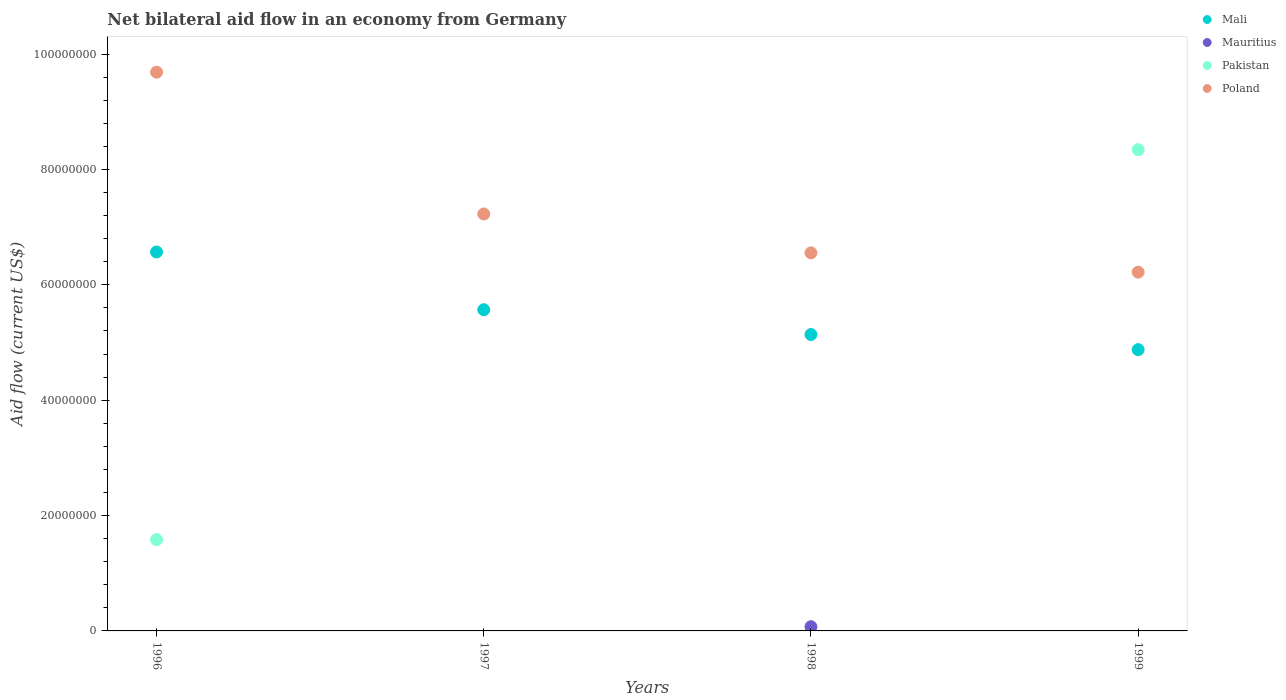How many different coloured dotlines are there?
Offer a terse response. 4. Is the number of dotlines equal to the number of legend labels?
Give a very brief answer. No. What is the net bilateral aid flow in Mali in 1996?
Offer a terse response. 6.57e+07. Across all years, what is the maximum net bilateral aid flow in Mauritius?
Keep it short and to the point. 7.30e+05. In which year was the net bilateral aid flow in Poland maximum?
Your response must be concise. 1996. What is the total net bilateral aid flow in Mauritius in the graph?
Your response must be concise. 7.30e+05. What is the difference between the net bilateral aid flow in Mali in 1998 and that in 1999?
Your response must be concise. 2.62e+06. What is the difference between the net bilateral aid flow in Poland in 1997 and the net bilateral aid flow in Mauritius in 1999?
Offer a very short reply. 7.23e+07. What is the average net bilateral aid flow in Pakistan per year?
Give a very brief answer. 2.48e+07. In the year 1998, what is the difference between the net bilateral aid flow in Mauritius and net bilateral aid flow in Poland?
Offer a very short reply. -6.48e+07. In how many years, is the net bilateral aid flow in Mali greater than 92000000 US$?
Your response must be concise. 0. What is the ratio of the net bilateral aid flow in Mali in 1998 to that in 1999?
Your response must be concise. 1.05. Is the net bilateral aid flow in Poland in 1997 less than that in 1999?
Ensure brevity in your answer.  No. What is the difference between the highest and the second highest net bilateral aid flow in Mali?
Provide a succinct answer. 1.00e+07. What is the difference between the highest and the lowest net bilateral aid flow in Mali?
Keep it short and to the point. 1.69e+07. Is the sum of the net bilateral aid flow in Mali in 1996 and 1998 greater than the maximum net bilateral aid flow in Mauritius across all years?
Provide a short and direct response. Yes. Is it the case that in every year, the sum of the net bilateral aid flow in Mali and net bilateral aid flow in Mauritius  is greater than the net bilateral aid flow in Pakistan?
Keep it short and to the point. No. How many dotlines are there?
Your answer should be very brief. 4. How many years are there in the graph?
Offer a terse response. 4. What is the difference between two consecutive major ticks on the Y-axis?
Your answer should be compact. 2.00e+07. Are the values on the major ticks of Y-axis written in scientific E-notation?
Your answer should be very brief. No. Does the graph contain grids?
Give a very brief answer. No. Where does the legend appear in the graph?
Ensure brevity in your answer.  Top right. What is the title of the graph?
Your answer should be compact. Net bilateral aid flow in an economy from Germany. Does "Congo (Republic)" appear as one of the legend labels in the graph?
Your response must be concise. No. What is the label or title of the X-axis?
Provide a succinct answer. Years. What is the Aid flow (current US$) in Mali in 1996?
Your answer should be very brief. 6.57e+07. What is the Aid flow (current US$) in Mauritius in 1996?
Your answer should be very brief. 0. What is the Aid flow (current US$) of Pakistan in 1996?
Your answer should be compact. 1.58e+07. What is the Aid flow (current US$) of Poland in 1996?
Keep it short and to the point. 9.69e+07. What is the Aid flow (current US$) of Mali in 1997?
Make the answer very short. 5.57e+07. What is the Aid flow (current US$) of Mauritius in 1997?
Offer a terse response. 0. What is the Aid flow (current US$) in Poland in 1997?
Provide a succinct answer. 7.23e+07. What is the Aid flow (current US$) in Mali in 1998?
Make the answer very short. 5.14e+07. What is the Aid flow (current US$) in Mauritius in 1998?
Make the answer very short. 7.30e+05. What is the Aid flow (current US$) in Pakistan in 1998?
Your response must be concise. 0. What is the Aid flow (current US$) of Poland in 1998?
Make the answer very short. 6.55e+07. What is the Aid flow (current US$) of Mali in 1999?
Your answer should be very brief. 4.88e+07. What is the Aid flow (current US$) in Pakistan in 1999?
Keep it short and to the point. 8.34e+07. What is the Aid flow (current US$) in Poland in 1999?
Offer a terse response. 6.22e+07. Across all years, what is the maximum Aid flow (current US$) of Mali?
Your answer should be very brief. 6.57e+07. Across all years, what is the maximum Aid flow (current US$) of Mauritius?
Offer a terse response. 7.30e+05. Across all years, what is the maximum Aid flow (current US$) of Pakistan?
Keep it short and to the point. 8.34e+07. Across all years, what is the maximum Aid flow (current US$) of Poland?
Your response must be concise. 9.69e+07. Across all years, what is the minimum Aid flow (current US$) of Mali?
Keep it short and to the point. 4.88e+07. Across all years, what is the minimum Aid flow (current US$) in Mauritius?
Give a very brief answer. 0. Across all years, what is the minimum Aid flow (current US$) of Pakistan?
Give a very brief answer. 0. Across all years, what is the minimum Aid flow (current US$) of Poland?
Your answer should be very brief. 6.22e+07. What is the total Aid flow (current US$) in Mali in the graph?
Keep it short and to the point. 2.22e+08. What is the total Aid flow (current US$) in Mauritius in the graph?
Make the answer very short. 7.30e+05. What is the total Aid flow (current US$) of Pakistan in the graph?
Your answer should be very brief. 9.92e+07. What is the total Aid flow (current US$) of Poland in the graph?
Your answer should be compact. 2.97e+08. What is the difference between the Aid flow (current US$) in Mali in 1996 and that in 1997?
Make the answer very short. 1.00e+07. What is the difference between the Aid flow (current US$) in Poland in 1996 and that in 1997?
Provide a short and direct response. 2.46e+07. What is the difference between the Aid flow (current US$) in Mali in 1996 and that in 1998?
Your response must be concise. 1.43e+07. What is the difference between the Aid flow (current US$) of Poland in 1996 and that in 1998?
Give a very brief answer. 3.13e+07. What is the difference between the Aid flow (current US$) of Mali in 1996 and that in 1999?
Keep it short and to the point. 1.69e+07. What is the difference between the Aid flow (current US$) in Pakistan in 1996 and that in 1999?
Keep it short and to the point. -6.76e+07. What is the difference between the Aid flow (current US$) in Poland in 1996 and that in 1999?
Offer a very short reply. 3.47e+07. What is the difference between the Aid flow (current US$) in Mali in 1997 and that in 1998?
Make the answer very short. 4.30e+06. What is the difference between the Aid flow (current US$) in Poland in 1997 and that in 1998?
Your answer should be very brief. 6.74e+06. What is the difference between the Aid flow (current US$) of Mali in 1997 and that in 1999?
Make the answer very short. 6.92e+06. What is the difference between the Aid flow (current US$) in Poland in 1997 and that in 1999?
Provide a short and direct response. 1.01e+07. What is the difference between the Aid flow (current US$) of Mali in 1998 and that in 1999?
Ensure brevity in your answer.  2.62e+06. What is the difference between the Aid flow (current US$) in Poland in 1998 and that in 1999?
Provide a short and direct response. 3.34e+06. What is the difference between the Aid flow (current US$) of Mali in 1996 and the Aid flow (current US$) of Poland in 1997?
Offer a very short reply. -6.59e+06. What is the difference between the Aid flow (current US$) in Pakistan in 1996 and the Aid flow (current US$) in Poland in 1997?
Give a very brief answer. -5.65e+07. What is the difference between the Aid flow (current US$) in Mali in 1996 and the Aid flow (current US$) in Mauritius in 1998?
Your answer should be very brief. 6.50e+07. What is the difference between the Aid flow (current US$) of Mali in 1996 and the Aid flow (current US$) of Poland in 1998?
Give a very brief answer. 1.50e+05. What is the difference between the Aid flow (current US$) of Pakistan in 1996 and the Aid flow (current US$) of Poland in 1998?
Your answer should be very brief. -4.97e+07. What is the difference between the Aid flow (current US$) of Mali in 1996 and the Aid flow (current US$) of Pakistan in 1999?
Give a very brief answer. -1.77e+07. What is the difference between the Aid flow (current US$) in Mali in 1996 and the Aid flow (current US$) in Poland in 1999?
Your response must be concise. 3.49e+06. What is the difference between the Aid flow (current US$) in Pakistan in 1996 and the Aid flow (current US$) in Poland in 1999?
Keep it short and to the point. -4.64e+07. What is the difference between the Aid flow (current US$) of Mali in 1997 and the Aid flow (current US$) of Mauritius in 1998?
Your answer should be very brief. 5.50e+07. What is the difference between the Aid flow (current US$) of Mali in 1997 and the Aid flow (current US$) of Poland in 1998?
Offer a very short reply. -9.86e+06. What is the difference between the Aid flow (current US$) of Mali in 1997 and the Aid flow (current US$) of Pakistan in 1999?
Your answer should be very brief. -2.78e+07. What is the difference between the Aid flow (current US$) in Mali in 1997 and the Aid flow (current US$) in Poland in 1999?
Offer a very short reply. -6.52e+06. What is the difference between the Aid flow (current US$) of Mali in 1998 and the Aid flow (current US$) of Pakistan in 1999?
Provide a short and direct response. -3.20e+07. What is the difference between the Aid flow (current US$) of Mali in 1998 and the Aid flow (current US$) of Poland in 1999?
Your answer should be compact. -1.08e+07. What is the difference between the Aid flow (current US$) in Mauritius in 1998 and the Aid flow (current US$) in Pakistan in 1999?
Make the answer very short. -8.27e+07. What is the difference between the Aid flow (current US$) of Mauritius in 1998 and the Aid flow (current US$) of Poland in 1999?
Your response must be concise. -6.15e+07. What is the average Aid flow (current US$) of Mali per year?
Give a very brief answer. 5.54e+07. What is the average Aid flow (current US$) in Mauritius per year?
Make the answer very short. 1.82e+05. What is the average Aid flow (current US$) in Pakistan per year?
Your answer should be very brief. 2.48e+07. What is the average Aid flow (current US$) of Poland per year?
Your response must be concise. 7.42e+07. In the year 1996, what is the difference between the Aid flow (current US$) of Mali and Aid flow (current US$) of Pakistan?
Provide a succinct answer. 4.99e+07. In the year 1996, what is the difference between the Aid flow (current US$) in Mali and Aid flow (current US$) in Poland?
Give a very brief answer. -3.12e+07. In the year 1996, what is the difference between the Aid flow (current US$) of Pakistan and Aid flow (current US$) of Poland?
Make the answer very short. -8.10e+07. In the year 1997, what is the difference between the Aid flow (current US$) in Mali and Aid flow (current US$) in Poland?
Provide a succinct answer. -1.66e+07. In the year 1998, what is the difference between the Aid flow (current US$) in Mali and Aid flow (current US$) in Mauritius?
Offer a very short reply. 5.06e+07. In the year 1998, what is the difference between the Aid flow (current US$) in Mali and Aid flow (current US$) in Poland?
Your answer should be compact. -1.42e+07. In the year 1998, what is the difference between the Aid flow (current US$) in Mauritius and Aid flow (current US$) in Poland?
Keep it short and to the point. -6.48e+07. In the year 1999, what is the difference between the Aid flow (current US$) in Mali and Aid flow (current US$) in Pakistan?
Your answer should be very brief. -3.47e+07. In the year 1999, what is the difference between the Aid flow (current US$) of Mali and Aid flow (current US$) of Poland?
Provide a short and direct response. -1.34e+07. In the year 1999, what is the difference between the Aid flow (current US$) in Pakistan and Aid flow (current US$) in Poland?
Your response must be concise. 2.12e+07. What is the ratio of the Aid flow (current US$) of Mali in 1996 to that in 1997?
Provide a succinct answer. 1.18. What is the ratio of the Aid flow (current US$) in Poland in 1996 to that in 1997?
Provide a succinct answer. 1.34. What is the ratio of the Aid flow (current US$) in Mali in 1996 to that in 1998?
Give a very brief answer. 1.28. What is the ratio of the Aid flow (current US$) of Poland in 1996 to that in 1998?
Your response must be concise. 1.48. What is the ratio of the Aid flow (current US$) in Mali in 1996 to that in 1999?
Offer a terse response. 1.35. What is the ratio of the Aid flow (current US$) in Pakistan in 1996 to that in 1999?
Your answer should be very brief. 0.19. What is the ratio of the Aid flow (current US$) of Poland in 1996 to that in 1999?
Your answer should be very brief. 1.56. What is the ratio of the Aid flow (current US$) of Mali in 1997 to that in 1998?
Your answer should be very brief. 1.08. What is the ratio of the Aid flow (current US$) in Poland in 1997 to that in 1998?
Provide a succinct answer. 1.1. What is the ratio of the Aid flow (current US$) in Mali in 1997 to that in 1999?
Your response must be concise. 1.14. What is the ratio of the Aid flow (current US$) of Poland in 1997 to that in 1999?
Provide a succinct answer. 1.16. What is the ratio of the Aid flow (current US$) of Mali in 1998 to that in 1999?
Provide a short and direct response. 1.05. What is the ratio of the Aid flow (current US$) in Poland in 1998 to that in 1999?
Make the answer very short. 1.05. What is the difference between the highest and the second highest Aid flow (current US$) in Mali?
Provide a short and direct response. 1.00e+07. What is the difference between the highest and the second highest Aid flow (current US$) of Poland?
Your response must be concise. 2.46e+07. What is the difference between the highest and the lowest Aid flow (current US$) of Mali?
Provide a short and direct response. 1.69e+07. What is the difference between the highest and the lowest Aid flow (current US$) of Mauritius?
Keep it short and to the point. 7.30e+05. What is the difference between the highest and the lowest Aid flow (current US$) in Pakistan?
Provide a succinct answer. 8.34e+07. What is the difference between the highest and the lowest Aid flow (current US$) in Poland?
Make the answer very short. 3.47e+07. 